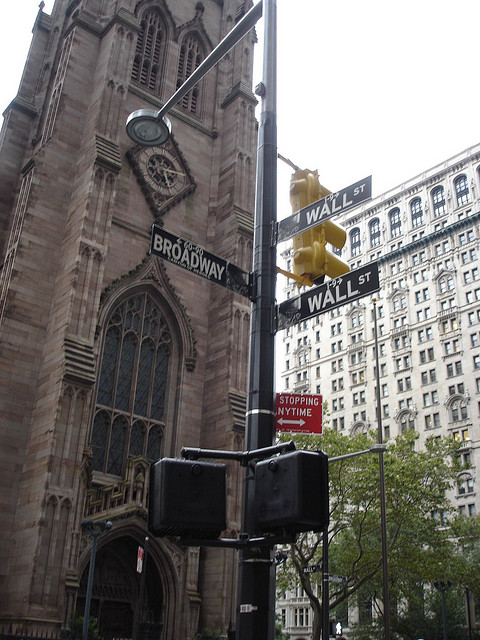Please transcribe the text information in this image. BROADWAY WALL s ST WALL s NYTIME STOPPING ST 